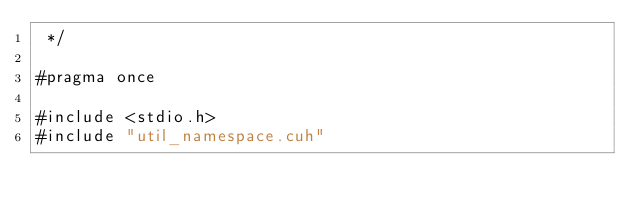<code> <loc_0><loc_0><loc_500><loc_500><_Cuda_> */

#pragma once

#include <stdio.h>
#include "util_namespace.cuh"</code> 